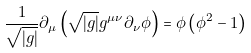<formula> <loc_0><loc_0><loc_500><loc_500>\frac { 1 } { \sqrt { | g | } } \partial _ { \mu } \left ( \sqrt { | g | } g ^ { \mu \nu } \partial _ { \nu } \phi \right ) = \phi \left ( \phi ^ { 2 } - 1 \right )</formula> 